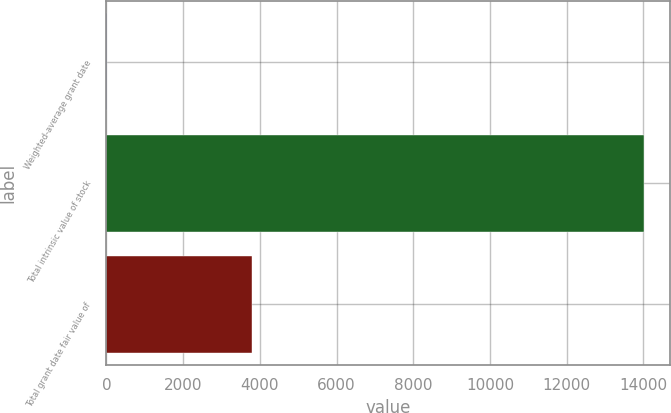<chart> <loc_0><loc_0><loc_500><loc_500><bar_chart><fcel>Weighted-average grant date<fcel>Total intrinsic value of stock<fcel>Total grant date fair value of<nl><fcel>8.23<fcel>14001<fcel>3796<nl></chart> 